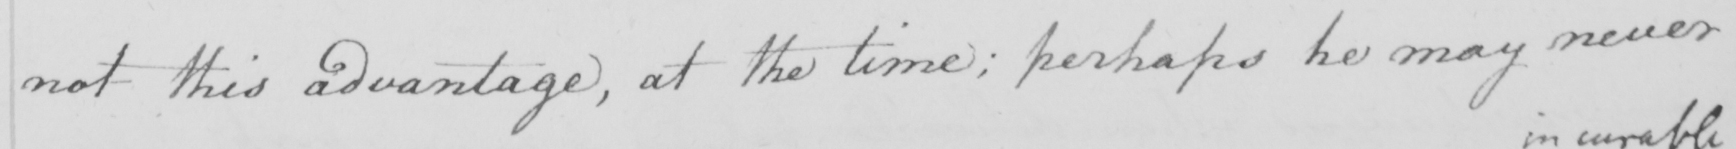Transcribe the text shown in this historical manuscript line. not this advantage , at the time :  perhaps he may never 